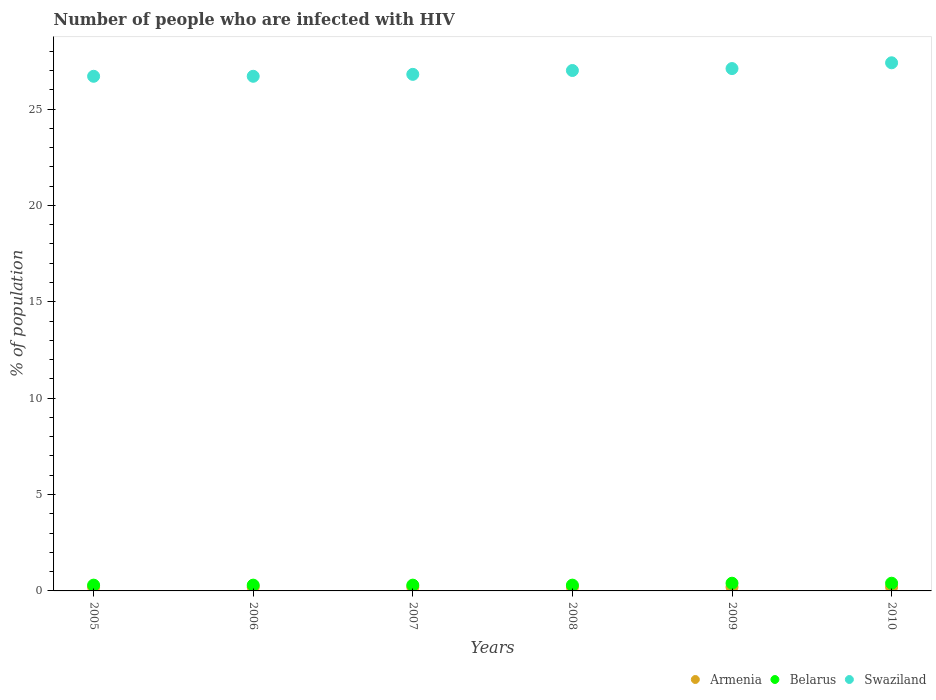How many different coloured dotlines are there?
Your answer should be very brief. 3. Is the number of dotlines equal to the number of legend labels?
Your answer should be very brief. Yes. What is the percentage of HIV infected population in in Swaziland in 2009?
Your answer should be very brief. 27.1. Across all years, what is the maximum percentage of HIV infected population in in Swaziland?
Provide a short and direct response. 27.4. Across all years, what is the minimum percentage of HIV infected population in in Belarus?
Provide a succinct answer. 0.3. In which year was the percentage of HIV infected population in in Swaziland maximum?
Ensure brevity in your answer.  2010. What is the total percentage of HIV infected population in in Armenia in the graph?
Make the answer very short. 1.2. What is the difference between the percentage of HIV infected population in in Armenia in 2005 and that in 2008?
Your answer should be compact. 0. What is the difference between the percentage of HIV infected population in in Armenia in 2007 and the percentage of HIV infected population in in Belarus in 2009?
Offer a terse response. -0.2. What is the average percentage of HIV infected population in in Armenia per year?
Make the answer very short. 0.2. In the year 2005, what is the difference between the percentage of HIV infected population in in Armenia and percentage of HIV infected population in in Swaziland?
Give a very brief answer. -26.5. What is the ratio of the percentage of HIV infected population in in Swaziland in 2009 to that in 2010?
Provide a succinct answer. 0.99. Is the percentage of HIV infected population in in Belarus in 2007 less than that in 2008?
Make the answer very short. No. Is the difference between the percentage of HIV infected population in in Armenia in 2009 and 2010 greater than the difference between the percentage of HIV infected population in in Swaziland in 2009 and 2010?
Your response must be concise. Yes. What is the difference between the highest and the lowest percentage of HIV infected population in in Armenia?
Your answer should be compact. 0. Is the sum of the percentage of HIV infected population in in Swaziland in 2005 and 2009 greater than the maximum percentage of HIV infected population in in Belarus across all years?
Your answer should be compact. Yes. Is the percentage of HIV infected population in in Swaziland strictly greater than the percentage of HIV infected population in in Armenia over the years?
Give a very brief answer. Yes. Is the percentage of HIV infected population in in Swaziland strictly less than the percentage of HIV infected population in in Armenia over the years?
Give a very brief answer. No. How many dotlines are there?
Give a very brief answer. 3. How many years are there in the graph?
Give a very brief answer. 6. What is the difference between two consecutive major ticks on the Y-axis?
Offer a terse response. 5. Are the values on the major ticks of Y-axis written in scientific E-notation?
Ensure brevity in your answer.  No. Does the graph contain grids?
Keep it short and to the point. No. Where does the legend appear in the graph?
Provide a short and direct response. Bottom right. How many legend labels are there?
Offer a very short reply. 3. What is the title of the graph?
Your answer should be compact. Number of people who are infected with HIV. Does "Syrian Arab Republic" appear as one of the legend labels in the graph?
Make the answer very short. No. What is the label or title of the X-axis?
Provide a succinct answer. Years. What is the label or title of the Y-axis?
Give a very brief answer. % of population. What is the % of population in Armenia in 2005?
Make the answer very short. 0.2. What is the % of population in Belarus in 2005?
Your response must be concise. 0.3. What is the % of population in Swaziland in 2005?
Keep it short and to the point. 26.7. What is the % of population in Swaziland in 2006?
Your answer should be very brief. 26.7. What is the % of population of Armenia in 2007?
Your answer should be very brief. 0.2. What is the % of population in Belarus in 2007?
Your response must be concise. 0.3. What is the % of population in Swaziland in 2007?
Offer a very short reply. 26.8. What is the % of population of Belarus in 2008?
Keep it short and to the point. 0.3. What is the % of population of Armenia in 2009?
Give a very brief answer. 0.2. What is the % of population in Swaziland in 2009?
Give a very brief answer. 27.1. What is the % of population in Swaziland in 2010?
Offer a very short reply. 27.4. Across all years, what is the maximum % of population of Armenia?
Make the answer very short. 0.2. Across all years, what is the maximum % of population in Belarus?
Give a very brief answer. 0.4. Across all years, what is the maximum % of population of Swaziland?
Provide a short and direct response. 27.4. Across all years, what is the minimum % of population of Swaziland?
Provide a short and direct response. 26.7. What is the total % of population of Belarus in the graph?
Your answer should be very brief. 2. What is the total % of population of Swaziland in the graph?
Your response must be concise. 161.7. What is the difference between the % of population of Armenia in 2005 and that in 2006?
Your response must be concise. 0. What is the difference between the % of population in Swaziland in 2005 and that in 2006?
Provide a short and direct response. 0. What is the difference between the % of population in Armenia in 2005 and that in 2007?
Give a very brief answer. 0. What is the difference between the % of population in Swaziland in 2005 and that in 2007?
Your response must be concise. -0.1. What is the difference between the % of population of Belarus in 2005 and that in 2008?
Keep it short and to the point. 0. What is the difference between the % of population in Belarus in 2005 and that in 2009?
Offer a terse response. -0.1. What is the difference between the % of population in Swaziland in 2005 and that in 2009?
Your answer should be compact. -0.4. What is the difference between the % of population of Armenia in 2005 and that in 2010?
Offer a very short reply. 0. What is the difference between the % of population in Belarus in 2005 and that in 2010?
Give a very brief answer. -0.1. What is the difference between the % of population in Armenia in 2006 and that in 2007?
Provide a succinct answer. 0. What is the difference between the % of population in Belarus in 2006 and that in 2007?
Offer a very short reply. 0. What is the difference between the % of population in Belarus in 2006 and that in 2008?
Provide a succinct answer. 0. What is the difference between the % of population of Swaziland in 2006 and that in 2008?
Make the answer very short. -0.3. What is the difference between the % of population in Armenia in 2006 and that in 2009?
Offer a terse response. 0. What is the difference between the % of population in Belarus in 2006 and that in 2010?
Offer a very short reply. -0.1. What is the difference between the % of population of Swaziland in 2006 and that in 2010?
Provide a succinct answer. -0.7. What is the difference between the % of population of Belarus in 2007 and that in 2008?
Ensure brevity in your answer.  0. What is the difference between the % of population in Swaziland in 2007 and that in 2009?
Offer a terse response. -0.3. What is the difference between the % of population in Armenia in 2007 and that in 2010?
Give a very brief answer. 0. What is the difference between the % of population in Belarus in 2007 and that in 2010?
Your answer should be compact. -0.1. What is the difference between the % of population in Swaziland in 2008 and that in 2009?
Make the answer very short. -0.1. What is the difference between the % of population of Belarus in 2008 and that in 2010?
Offer a very short reply. -0.1. What is the difference between the % of population of Belarus in 2009 and that in 2010?
Offer a terse response. 0. What is the difference between the % of population of Swaziland in 2009 and that in 2010?
Keep it short and to the point. -0.3. What is the difference between the % of population of Armenia in 2005 and the % of population of Swaziland in 2006?
Make the answer very short. -26.5. What is the difference between the % of population in Belarus in 2005 and the % of population in Swaziland in 2006?
Offer a terse response. -26.4. What is the difference between the % of population of Armenia in 2005 and the % of population of Belarus in 2007?
Your answer should be very brief. -0.1. What is the difference between the % of population in Armenia in 2005 and the % of population in Swaziland in 2007?
Your answer should be compact. -26.6. What is the difference between the % of population of Belarus in 2005 and the % of population of Swaziland in 2007?
Ensure brevity in your answer.  -26.5. What is the difference between the % of population of Armenia in 2005 and the % of population of Belarus in 2008?
Your answer should be very brief. -0.1. What is the difference between the % of population in Armenia in 2005 and the % of population in Swaziland in 2008?
Offer a very short reply. -26.8. What is the difference between the % of population in Belarus in 2005 and the % of population in Swaziland in 2008?
Offer a terse response. -26.7. What is the difference between the % of population in Armenia in 2005 and the % of population in Swaziland in 2009?
Provide a short and direct response. -26.9. What is the difference between the % of population in Belarus in 2005 and the % of population in Swaziland in 2009?
Make the answer very short. -26.8. What is the difference between the % of population in Armenia in 2005 and the % of population in Belarus in 2010?
Your answer should be very brief. -0.2. What is the difference between the % of population of Armenia in 2005 and the % of population of Swaziland in 2010?
Your answer should be compact. -27.2. What is the difference between the % of population in Belarus in 2005 and the % of population in Swaziland in 2010?
Keep it short and to the point. -27.1. What is the difference between the % of population in Armenia in 2006 and the % of population in Belarus in 2007?
Your answer should be compact. -0.1. What is the difference between the % of population of Armenia in 2006 and the % of population of Swaziland in 2007?
Your answer should be compact. -26.6. What is the difference between the % of population of Belarus in 2006 and the % of population of Swaziland in 2007?
Ensure brevity in your answer.  -26.5. What is the difference between the % of population of Armenia in 2006 and the % of population of Belarus in 2008?
Your response must be concise. -0.1. What is the difference between the % of population of Armenia in 2006 and the % of population of Swaziland in 2008?
Keep it short and to the point. -26.8. What is the difference between the % of population of Belarus in 2006 and the % of population of Swaziland in 2008?
Your answer should be very brief. -26.7. What is the difference between the % of population of Armenia in 2006 and the % of population of Swaziland in 2009?
Give a very brief answer. -26.9. What is the difference between the % of population of Belarus in 2006 and the % of population of Swaziland in 2009?
Your answer should be very brief. -26.8. What is the difference between the % of population in Armenia in 2006 and the % of population in Swaziland in 2010?
Your answer should be compact. -27.2. What is the difference between the % of population in Belarus in 2006 and the % of population in Swaziland in 2010?
Provide a succinct answer. -27.1. What is the difference between the % of population in Armenia in 2007 and the % of population in Belarus in 2008?
Your response must be concise. -0.1. What is the difference between the % of population of Armenia in 2007 and the % of population of Swaziland in 2008?
Offer a very short reply. -26.8. What is the difference between the % of population of Belarus in 2007 and the % of population of Swaziland in 2008?
Provide a succinct answer. -26.7. What is the difference between the % of population in Armenia in 2007 and the % of population in Belarus in 2009?
Your response must be concise. -0.2. What is the difference between the % of population of Armenia in 2007 and the % of population of Swaziland in 2009?
Provide a succinct answer. -26.9. What is the difference between the % of population in Belarus in 2007 and the % of population in Swaziland in 2009?
Provide a succinct answer. -26.8. What is the difference between the % of population of Armenia in 2007 and the % of population of Belarus in 2010?
Offer a terse response. -0.2. What is the difference between the % of population of Armenia in 2007 and the % of population of Swaziland in 2010?
Give a very brief answer. -27.2. What is the difference between the % of population of Belarus in 2007 and the % of population of Swaziland in 2010?
Provide a succinct answer. -27.1. What is the difference between the % of population in Armenia in 2008 and the % of population in Swaziland in 2009?
Offer a very short reply. -26.9. What is the difference between the % of population in Belarus in 2008 and the % of population in Swaziland in 2009?
Keep it short and to the point. -26.8. What is the difference between the % of population in Armenia in 2008 and the % of population in Swaziland in 2010?
Ensure brevity in your answer.  -27.2. What is the difference between the % of population of Belarus in 2008 and the % of population of Swaziland in 2010?
Your answer should be very brief. -27.1. What is the difference between the % of population in Armenia in 2009 and the % of population in Swaziland in 2010?
Your response must be concise. -27.2. What is the average % of population in Belarus per year?
Ensure brevity in your answer.  0.33. What is the average % of population of Swaziland per year?
Offer a terse response. 26.95. In the year 2005, what is the difference between the % of population in Armenia and % of population in Belarus?
Your answer should be compact. -0.1. In the year 2005, what is the difference between the % of population in Armenia and % of population in Swaziland?
Your answer should be compact. -26.5. In the year 2005, what is the difference between the % of population in Belarus and % of population in Swaziland?
Ensure brevity in your answer.  -26.4. In the year 2006, what is the difference between the % of population of Armenia and % of population of Swaziland?
Give a very brief answer. -26.5. In the year 2006, what is the difference between the % of population of Belarus and % of population of Swaziland?
Keep it short and to the point. -26.4. In the year 2007, what is the difference between the % of population in Armenia and % of population in Swaziland?
Your answer should be compact. -26.6. In the year 2007, what is the difference between the % of population in Belarus and % of population in Swaziland?
Provide a succinct answer. -26.5. In the year 2008, what is the difference between the % of population of Armenia and % of population of Belarus?
Provide a short and direct response. -0.1. In the year 2008, what is the difference between the % of population in Armenia and % of population in Swaziland?
Keep it short and to the point. -26.8. In the year 2008, what is the difference between the % of population of Belarus and % of population of Swaziland?
Your response must be concise. -26.7. In the year 2009, what is the difference between the % of population in Armenia and % of population in Belarus?
Provide a succinct answer. -0.2. In the year 2009, what is the difference between the % of population in Armenia and % of population in Swaziland?
Your answer should be compact. -26.9. In the year 2009, what is the difference between the % of population in Belarus and % of population in Swaziland?
Make the answer very short. -26.7. In the year 2010, what is the difference between the % of population in Armenia and % of population in Belarus?
Give a very brief answer. -0.2. In the year 2010, what is the difference between the % of population of Armenia and % of population of Swaziland?
Your answer should be very brief. -27.2. What is the ratio of the % of population of Armenia in 2005 to that in 2007?
Your answer should be compact. 1. What is the ratio of the % of population in Swaziland in 2005 to that in 2007?
Your response must be concise. 1. What is the ratio of the % of population of Armenia in 2005 to that in 2008?
Make the answer very short. 1. What is the ratio of the % of population of Swaziland in 2005 to that in 2008?
Provide a short and direct response. 0.99. What is the ratio of the % of population of Armenia in 2005 to that in 2009?
Offer a very short reply. 1. What is the ratio of the % of population of Swaziland in 2005 to that in 2009?
Make the answer very short. 0.99. What is the ratio of the % of population in Swaziland in 2005 to that in 2010?
Your answer should be very brief. 0.97. What is the ratio of the % of population of Armenia in 2006 to that in 2007?
Keep it short and to the point. 1. What is the ratio of the % of population of Belarus in 2006 to that in 2007?
Offer a very short reply. 1. What is the ratio of the % of population of Swaziland in 2006 to that in 2007?
Give a very brief answer. 1. What is the ratio of the % of population in Swaziland in 2006 to that in 2008?
Give a very brief answer. 0.99. What is the ratio of the % of population of Armenia in 2006 to that in 2009?
Offer a very short reply. 1. What is the ratio of the % of population in Belarus in 2006 to that in 2009?
Provide a succinct answer. 0.75. What is the ratio of the % of population of Swaziland in 2006 to that in 2009?
Provide a short and direct response. 0.99. What is the ratio of the % of population of Armenia in 2006 to that in 2010?
Your response must be concise. 1. What is the ratio of the % of population of Swaziland in 2006 to that in 2010?
Your answer should be compact. 0.97. What is the ratio of the % of population of Armenia in 2007 to that in 2008?
Keep it short and to the point. 1. What is the ratio of the % of population in Belarus in 2007 to that in 2008?
Give a very brief answer. 1. What is the ratio of the % of population in Armenia in 2007 to that in 2009?
Ensure brevity in your answer.  1. What is the ratio of the % of population of Belarus in 2007 to that in 2009?
Your answer should be compact. 0.75. What is the ratio of the % of population in Swaziland in 2007 to that in 2009?
Ensure brevity in your answer.  0.99. What is the ratio of the % of population in Armenia in 2007 to that in 2010?
Keep it short and to the point. 1. What is the ratio of the % of population in Swaziland in 2007 to that in 2010?
Ensure brevity in your answer.  0.98. What is the ratio of the % of population in Swaziland in 2008 to that in 2009?
Offer a very short reply. 1. What is the ratio of the % of population of Belarus in 2008 to that in 2010?
Offer a terse response. 0.75. What is the ratio of the % of population of Swaziland in 2008 to that in 2010?
Ensure brevity in your answer.  0.99. What is the ratio of the % of population of Belarus in 2009 to that in 2010?
Provide a short and direct response. 1. What is the ratio of the % of population of Swaziland in 2009 to that in 2010?
Give a very brief answer. 0.99. What is the difference between the highest and the second highest % of population of Armenia?
Your answer should be very brief. 0. What is the difference between the highest and the second highest % of population in Swaziland?
Your answer should be compact. 0.3. What is the difference between the highest and the lowest % of population of Swaziland?
Your answer should be compact. 0.7. 